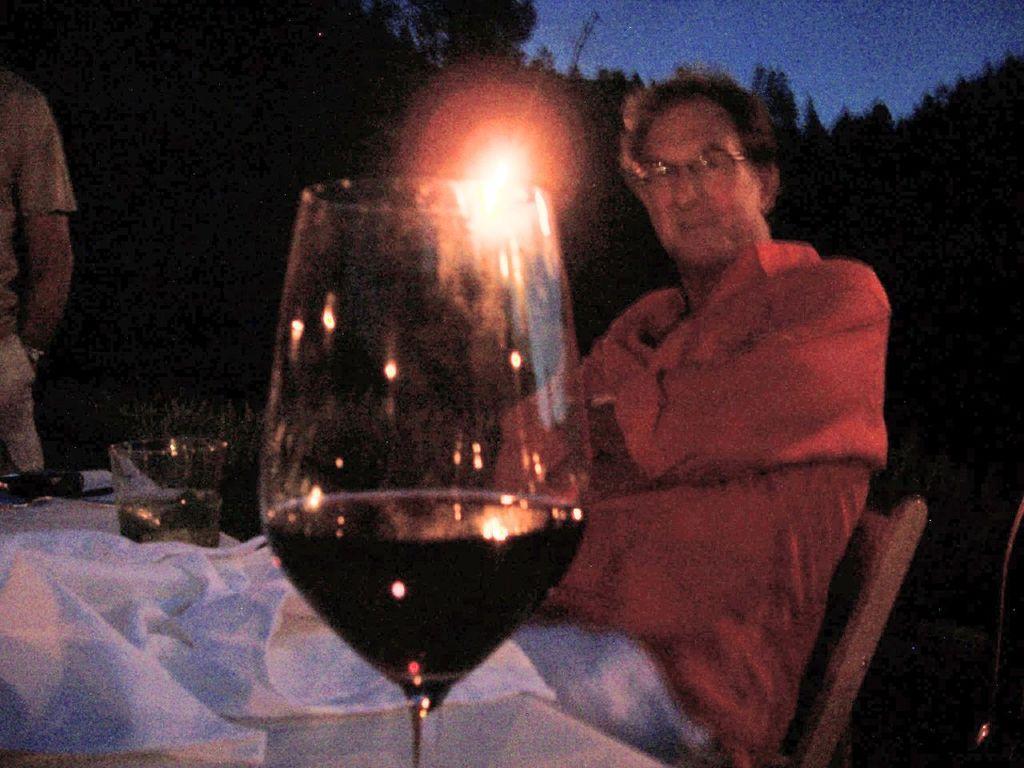Can you describe this image briefly? In this image, we can see a person wearing clothes and sitting on the chair in front of the table. This table contains glasses. There is a person hand on the left side of the image. There is a sky in the top right of the image. 